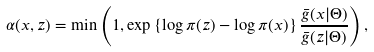Convert formula to latex. <formula><loc_0><loc_0><loc_500><loc_500>\alpha ( x , z ) = \min \left ( 1 , \exp \left \{ \log \pi ( z ) - \log \pi ( x ) \right \} \frac { \bar { g } ( x | \Theta ) } { \bar { g } ( z | \Theta ) } \right ) ,</formula> 